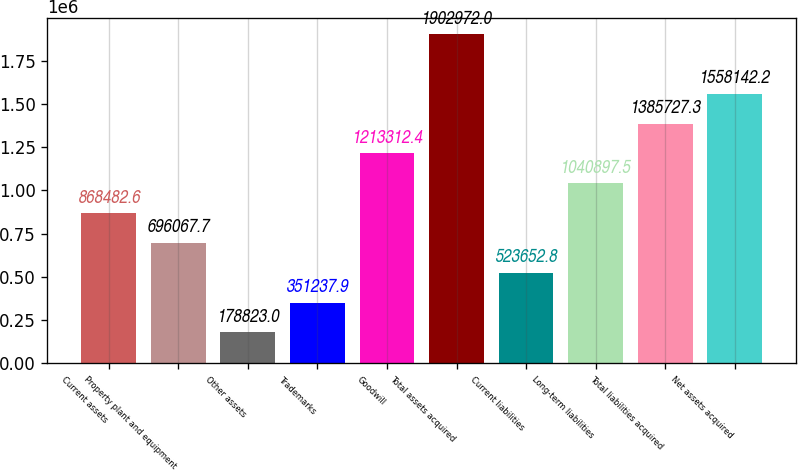Convert chart. <chart><loc_0><loc_0><loc_500><loc_500><bar_chart><fcel>Current assets<fcel>Property plant and equipment<fcel>Other assets<fcel>Trademarks<fcel>Goodwill<fcel>Total assets acquired<fcel>Current liabilities<fcel>Long-term liabilities<fcel>Total liabilities acquired<fcel>Net assets acquired<nl><fcel>868483<fcel>696068<fcel>178823<fcel>351238<fcel>1.21331e+06<fcel>1.90297e+06<fcel>523653<fcel>1.0409e+06<fcel>1.38573e+06<fcel>1.55814e+06<nl></chart> 